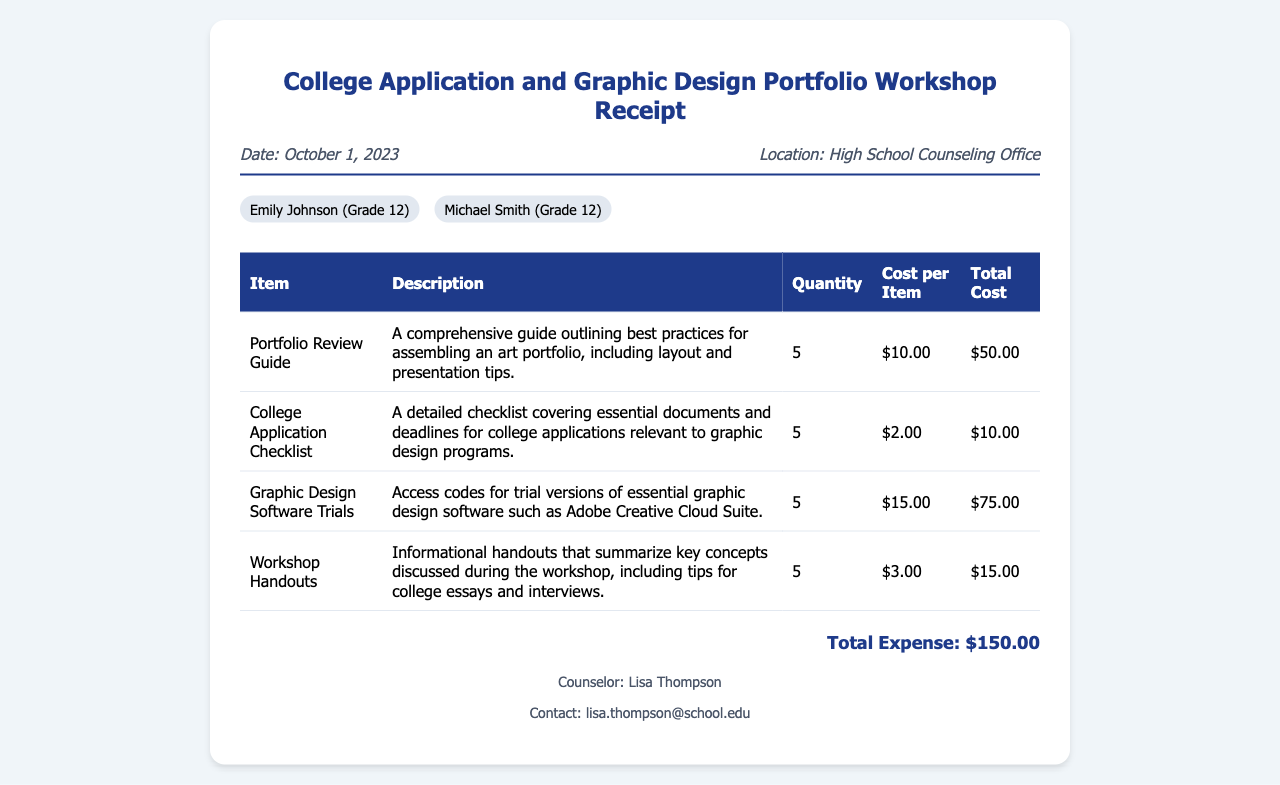What is the date of the workshop? The date is clearly stated at the top of the receipt as "October 1, 2023."
Answer: October 1, 2023 Who is the counselor listed on the receipt? The counselor's name is mentioned at the bottom of the document as "Lisa Thompson."
Answer: Lisa Thompson What is the total expense for the workshop? The total cost is calculated and displayed at the bottom of the receipt as "Total Expense: $150.00."
Answer: $150.00 How many Portfolio Review Guides were ordered? The quantity is shown in the table under the "Quantity" column for the Portfolio Review Guide.
Answer: 5 What type of workshop is this receipt for? The title of the document indicates it is for a "College Application and Graphic Design Portfolio Workshop."
Answer: College Application and Graphic Design Portfolio Workshop What is the cost per item for Graphic Design Software Trials? The cost per item can be found in the table, specifically for the Graphic Design Software Trials line.
Answer: $15.00 What kind of document is this? The document type is identified through its title and content structure, specifically labeled as a receipt.
Answer: Receipt What are the names of the participants? The names of participants are listed in the document under the participants section: "Emily Johnson (Grade 12)" and "Michael Smith (Grade 12)."
Answer: Emily Johnson, Michael Smith 